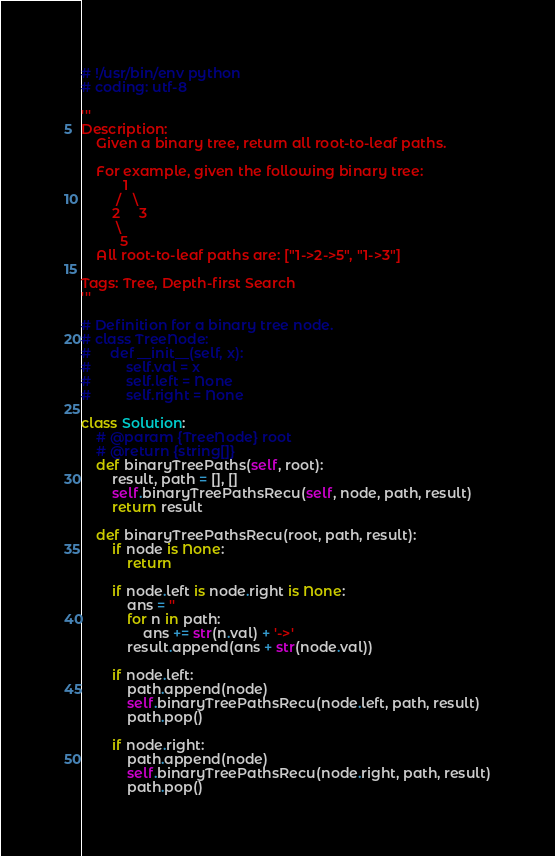Convert code to text. <code><loc_0><loc_0><loc_500><loc_500><_Python_># !/usr/bin/env python
# coding: utf-8

'''
Description:
    Given a binary tree, return all root-to-leaf paths.

    For example, given the following binary tree:
           1
         /   \
        2     3
         \
          5
    All root-to-leaf paths are: ["1->2->5", "1->3"]

Tags: Tree, Depth-first Search
'''

# Definition for a binary tree node.
# class TreeNode:
#     def __init__(self, x):
#         self.val = x
#         self.left = None
#         self.right = None

class Solution:
    # @param {TreeNode} root
    # @return {string[]}
    def binaryTreePaths(self, root):
        result, path = [], []
        self.binaryTreePathsRecu(self, node, path, result)
        return result

    def binaryTreePathsRecu(root, path, result):
        if node is None:
            return

        if node.left is node.right is None:
            ans = ''
            for n in path:
                ans += str(n.val) + '->'
            result.append(ans + str(node.val))

        if node.left:
            path.append(node)
            self.binaryTreePathsRecu(node.left, path, result)
            path.pop()

        if node.right:
            path.append(node)
            self.binaryTreePathsRecu(node.right, path, result)
            path.pop()
</code> 